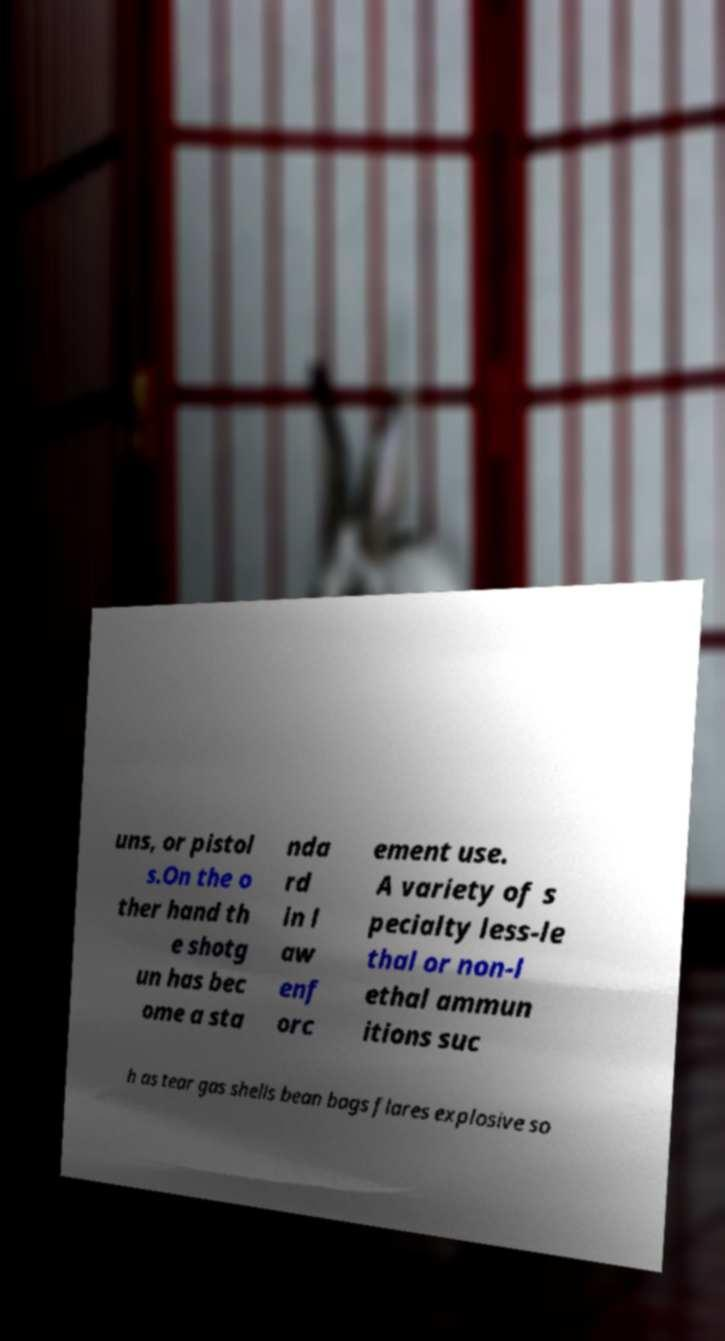Can you accurately transcribe the text from the provided image for me? uns, or pistol s.On the o ther hand th e shotg un has bec ome a sta nda rd in l aw enf orc ement use. A variety of s pecialty less-le thal or non-l ethal ammun itions suc h as tear gas shells bean bags flares explosive so 